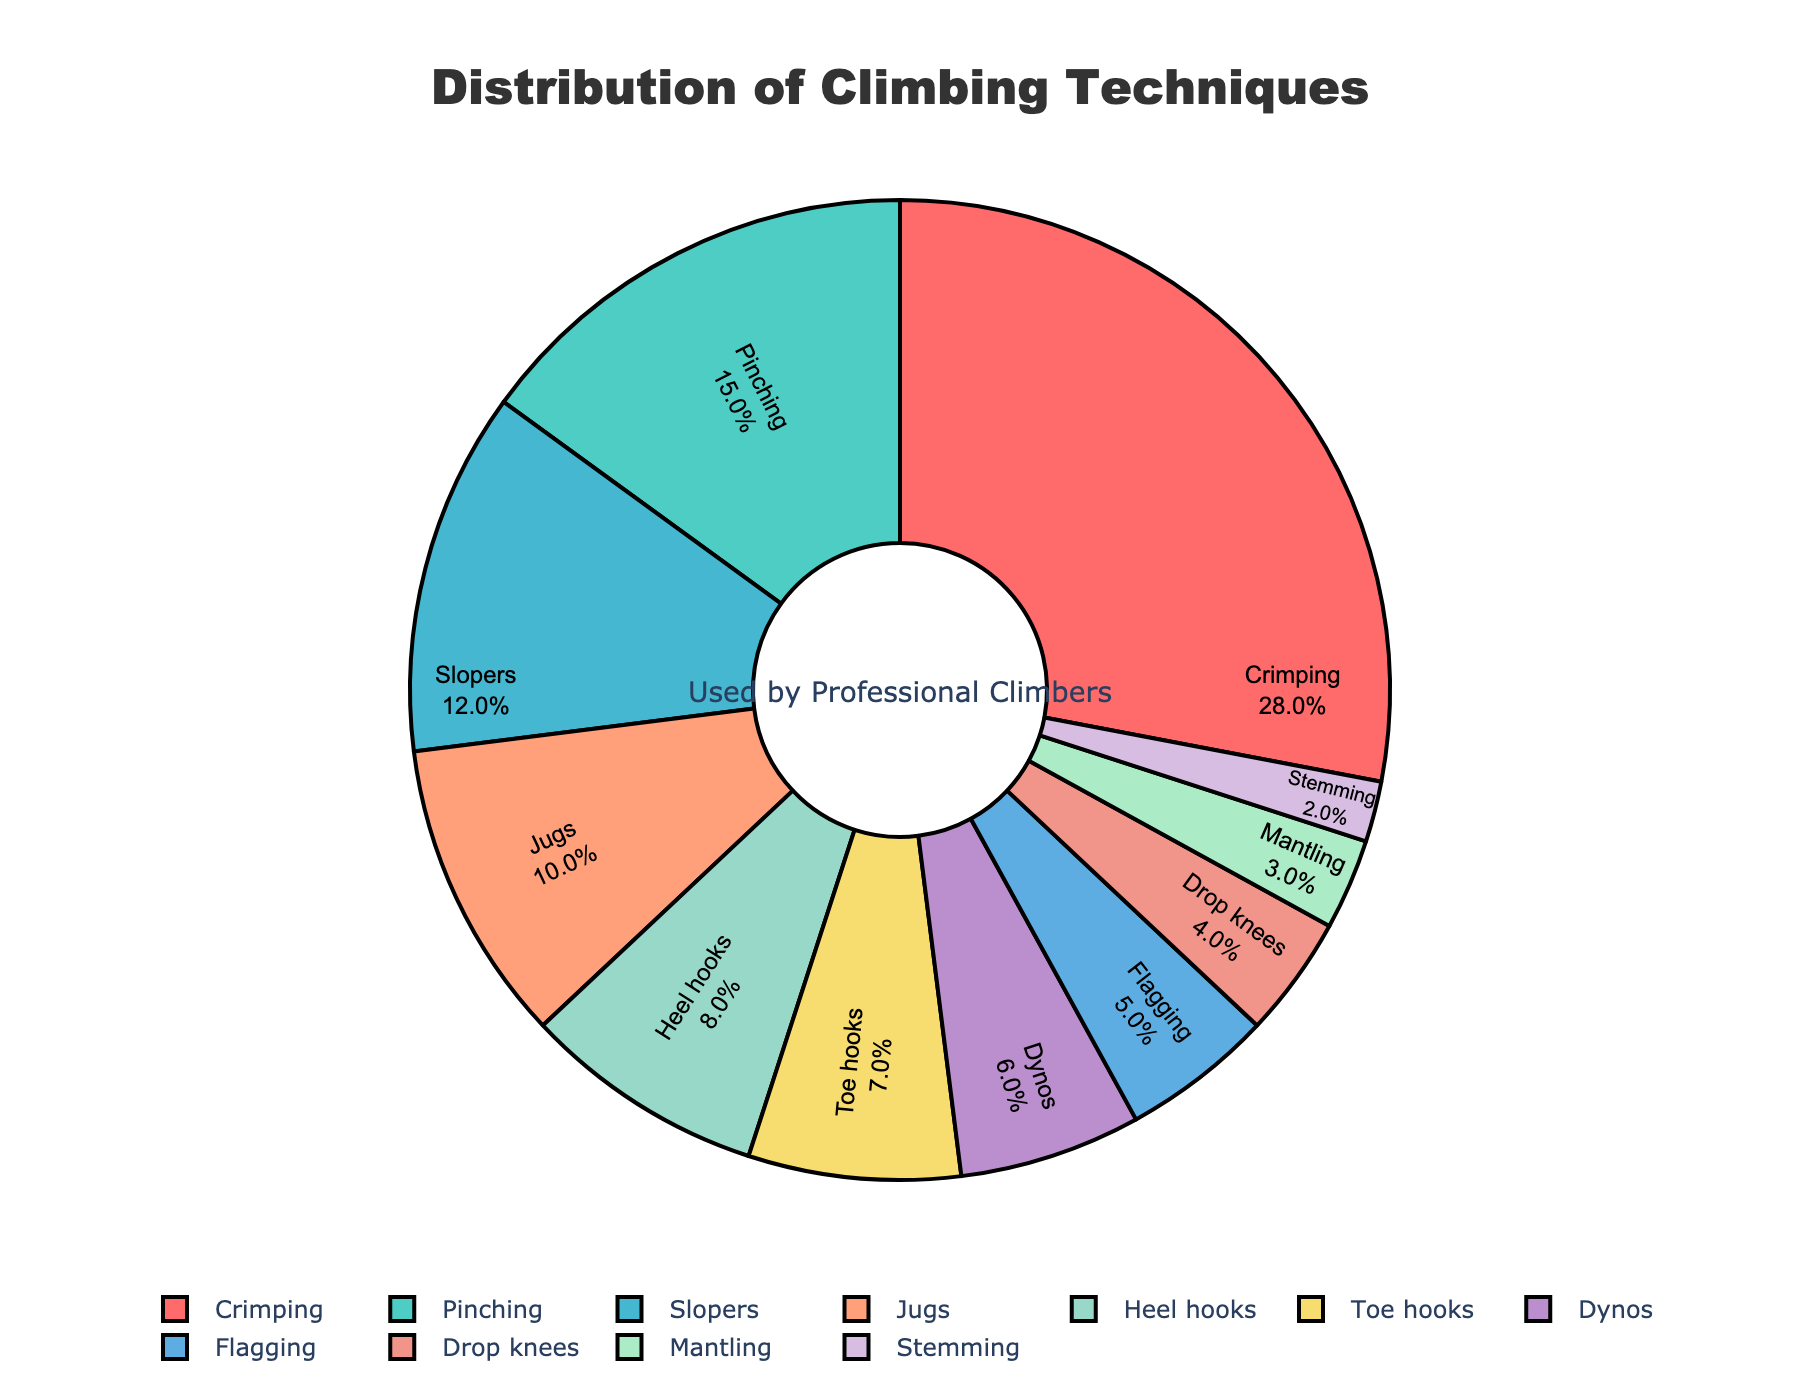What percentage of climbers use Crimping? The percentage for each climbing technique is clearly labeled inside the pie chart. Look for "Crimping" and observe the associated percentage value.
Answer: 28% How much more popular is Pinching compared to Dynos? Locate the percentages for Pinching and Dynos in the pie chart. Pinching is 15%, and Dynos is 6%. Subtract the percentage of Dynos from Pinching: 15% - 6% = 9%.
Answer: 9% What is the combined percentage of climbers using Slopers and Jugs? Identify and sum the percentages for Slopers and Jugs. Slopers is 12%, and Jugs is 10%. Adding them together gives 12% + 10% = 22%.
Answer: 22% Which technique is the least used by climbers? Scan the pie chart for the technique with the smallest percentage. Stemming has the lowest value at 2%.
Answer: Stemming Are there more climbers using Heel hooks or Toe hooks, and by how much? Compare the percentages of Heel hooks and Toe hooks. Heel hooks are at 8%, and Toe hooks are at 7%. Subtract Toe hooks from Heel hooks: 8% - 7% = 1%.
Answer: Heel hooks by 1% What is the combined percentage of all techniques less popular than Jugs? Identify techniques with percentages less than Jugs (10%): Heel hooks (8%), Toe hooks (7%), Dynos (6%), Flagging (5%), Drop knees (4%), Mantling (3%), Stemming (2%). Add these values together: 8% + 7% + 6% + 5% + 4% + 3% + 2% = 35%.
Answer: 35% What technique falls into the middle of the distribution? Ordered percentage values from high to low are: Crimping (28%), Pinching (15%), Slopers (12%), Jugs (10%), Heel hooks (8%), Toe hooks (7%), Dynos (6%), Flagging (5%), Drop knees (4%), Mantling (3%), Stemming (2%). The middle value (median) is Heel hooks at 8%.
Answer: Heel hooks Which color represents the technique with the second-highest percentage? Pinching has the second-highest percentage (15%). Identifying the segment color for Pinching, it is green.
Answer: Green What is the total percentage of climbers using either Flagging or Drop knees? Find and add the percentages of Flagging and Drop knees. Flagging is 5%, and Drop knees is 4%. Adding them together gives 5% + 4% = 9%.
Answer: 9% Which techniques combined have a higher prevalence than Crimping alone? Techniques include Pinching (15%), Slopers (12%), and Jugs (10%). Adding these: 15% + 12% + 10% = 37%, which is greater than Crimping's 28%.
Answer: Pinching, Slopers, Jugs 